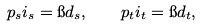<formula> <loc_0><loc_0><loc_500><loc_500>p _ { s } i _ { s } = \i d _ { s } , \quad p _ { t } i _ { t } = \i d _ { t } ,</formula> 